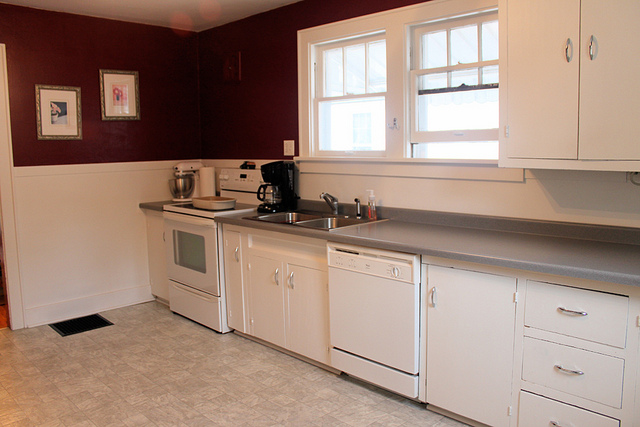Describe the layout of the kitchen. The kitchen layout features a linear arrangement of countertops and cabinetry along one wall. The sink is centrally located, flanked by the dishwasher on the right and the oven on the left. Above the countertops are upper cabinets, with appliances such as a mixer and coffee maker placed on the counter for easy access. This efficient layout maximizes functionality within a compact space. What kind of countertop material is used? The countertops appear to be made of a durable laminate material, which is both practical and budget-friendly. Laminate countertops are easy to clean and available in a variety of colors and patterns, making them a popular choice for kitchens. Are there any unique design elements in the kitchen? One unique design element in this kitchen is the contrasting color scheme, with deep burgundy or maroon walls paired with white cabinetry. This bold choice creates a striking visual impact, adding personality and warmth to the space. Additionally, the presence of artwork and a mix of countertop appliances suggests a thoughtful balance between aesthetics and functionality. 